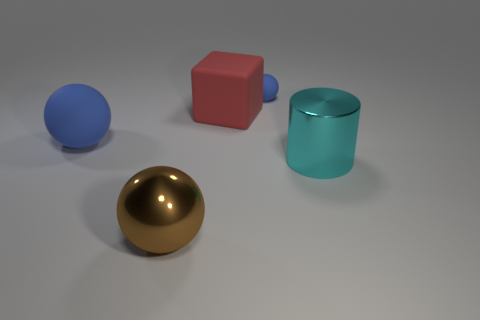Does the blue sphere left of the large red thing have the same material as the blue thing that is behind the big matte ball?
Make the answer very short. Yes. There is a red matte object; what shape is it?
Give a very brief answer. Cube. Is the number of big red matte things in front of the big cyan thing the same as the number of large yellow blocks?
Provide a succinct answer. Yes. There is a matte thing that is the same color as the big rubber sphere; what is its size?
Offer a very short reply. Small. Is there a blue thing made of the same material as the brown ball?
Provide a succinct answer. No. Does the brown metallic object that is in front of the large blue object have the same shape as the blue object that is in front of the red object?
Keep it short and to the point. Yes. Are any small purple matte cubes visible?
Your answer should be very brief. No. There is a cube that is the same size as the cyan object; what is its color?
Provide a short and direct response. Red. What number of large cyan shiny things are the same shape as the red rubber object?
Provide a succinct answer. 0. Does the ball that is right of the red object have the same material as the big brown ball?
Offer a very short reply. No. 